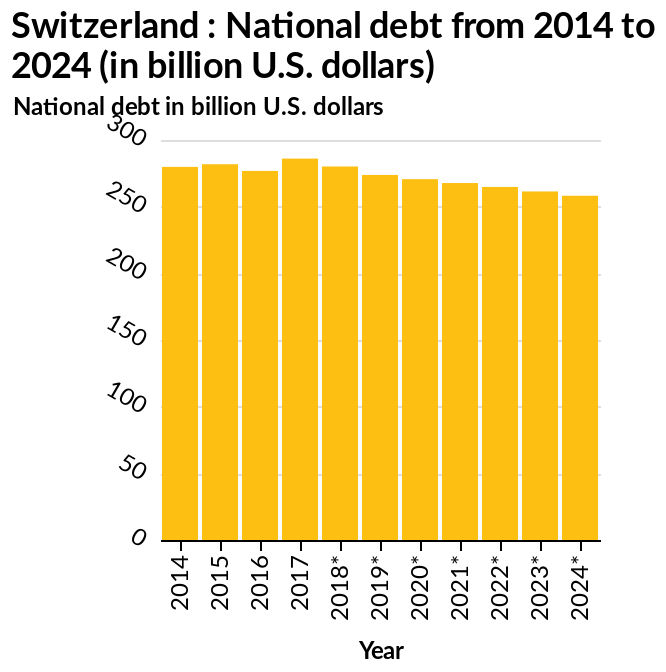<image>
What can be predicted about Sweden's national debt based on the information provided? Based on the information provided, we can predict that Sweden's national debt will continue to decline at a slow pace. What is the unit of measurement used for the national debt on the y-axis?  The unit of measurement is billion U.S. dollars. What is the range in billion U.S. dollars in which the national debt is shown on the y-axis?  The range is from 0 to 300 billion U.S. dollars. What type of plot is used to represent the national debt from 2014 to 2024? A bar plot is used to represent the national debt from 2014 to 2024. 